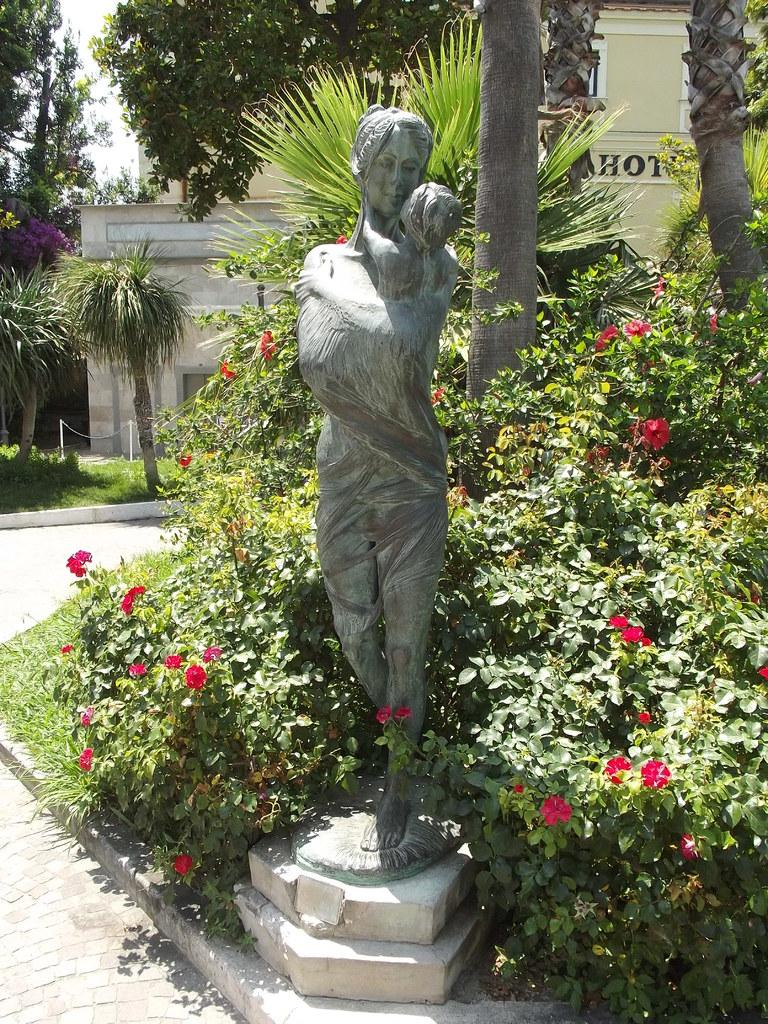What is the main subject in the image? There is a statue in the image. What type of vegetation can be seen in the image? There are flowers on plants in the image. What can be seen in the background of the image? There is a group of trees, grass, a building with text, and the sky visible in the background of the image. Can you see a squirrel climbing on the statue in the image? There is no squirrel present on the statue or in the image. What type of cork is used to hold the building's text in place in the image? There is no cork present in the image; the text is part of the building's design. 